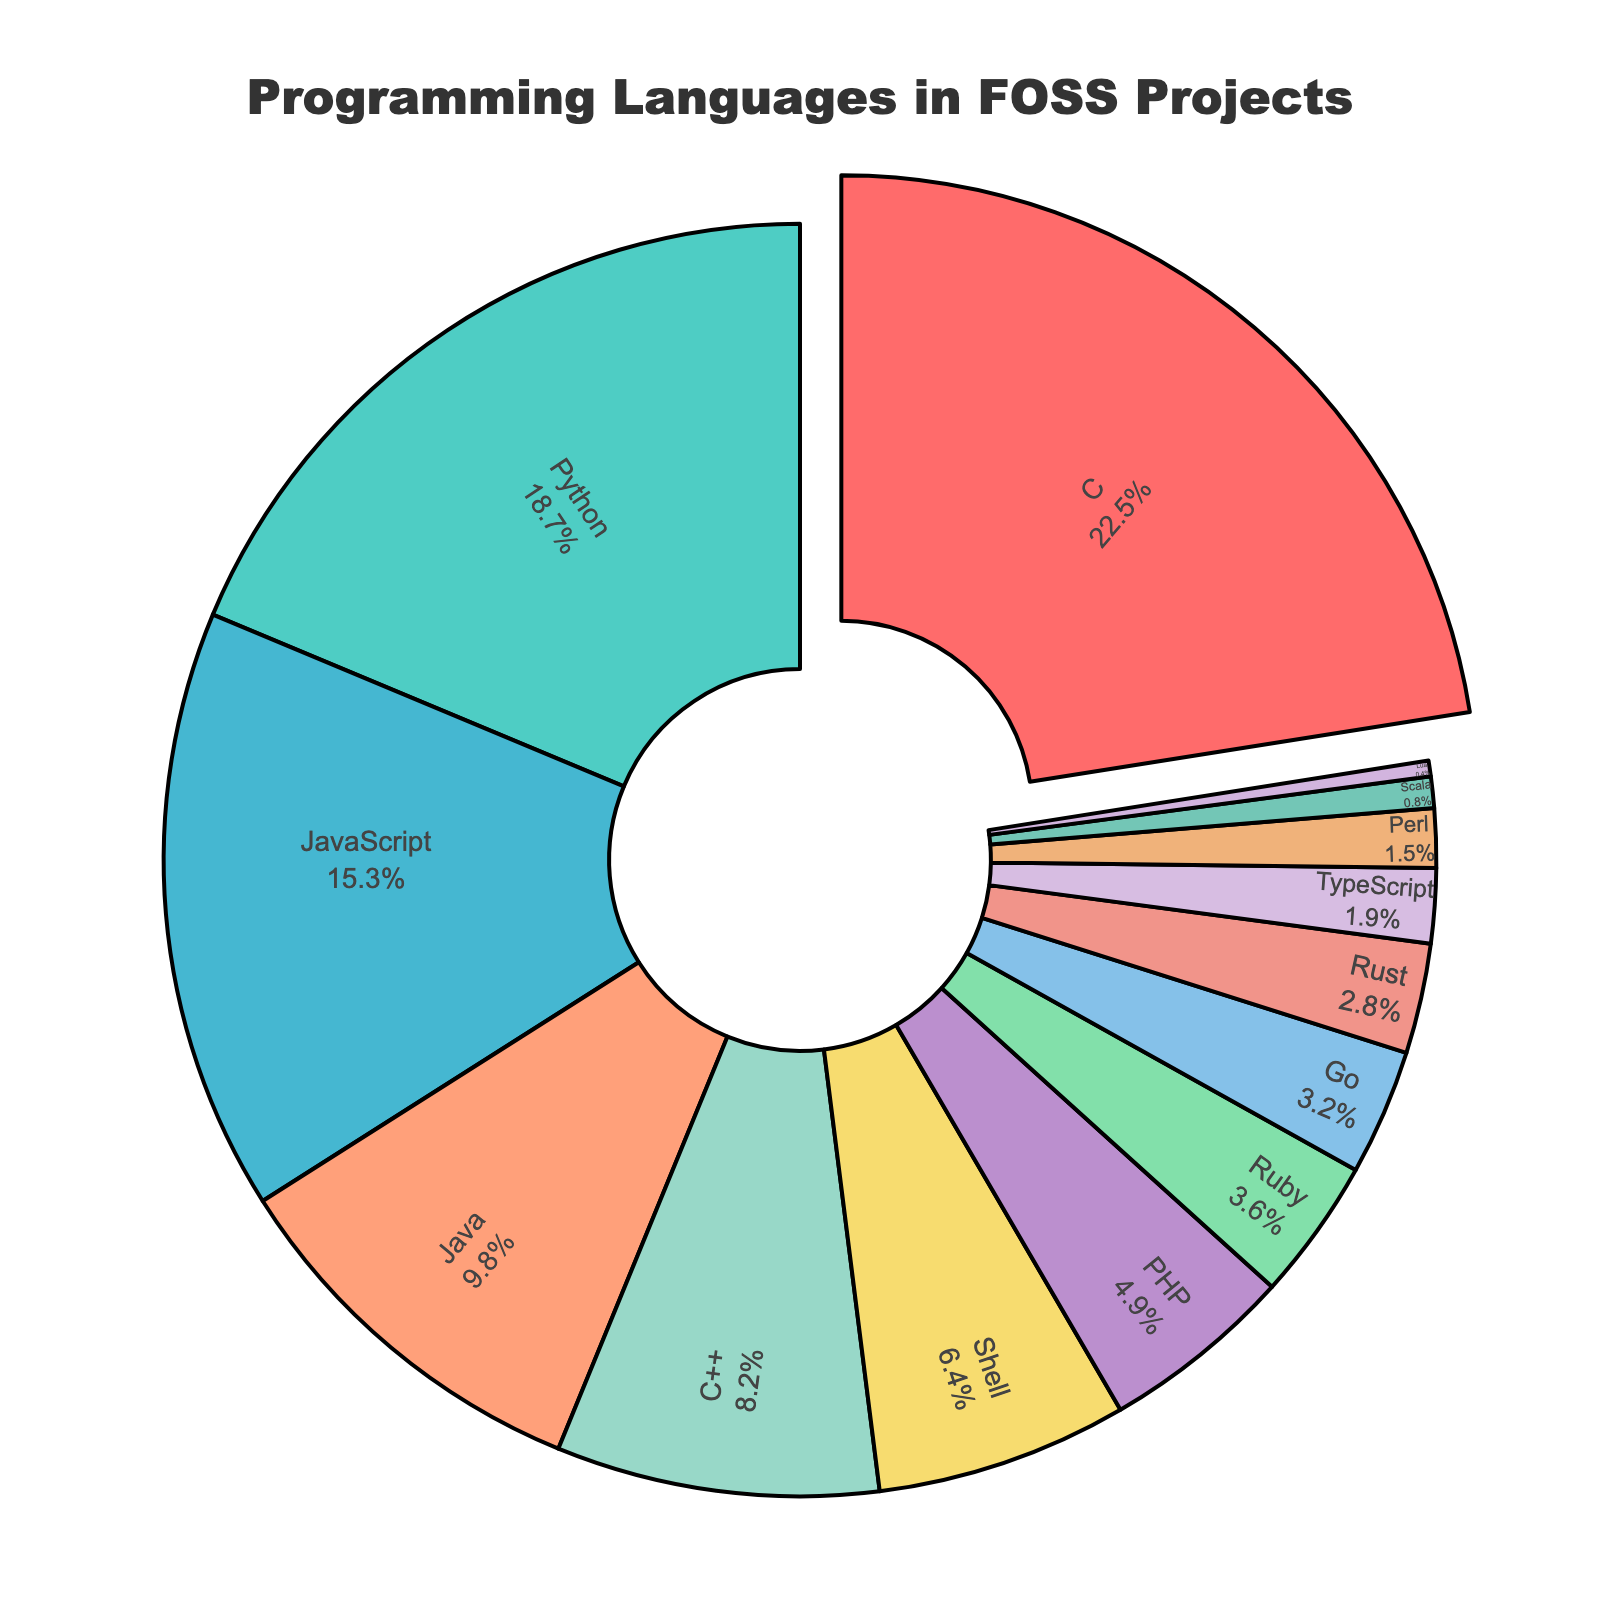Which language accounts for the largest percentage of use in FOSS projects? The pie chart shows each programming language's percentage of use in FOSS projects with the largest segment highlighted. The largest percentage indicated is for C.
Answer: C What is the combined percentage of JavaScript and Python usage? According to the pie chart, JavaScript accounts for 15.3% and Python accounts for 18.7%. Adding these two gives 15.3% + 18.7% = 34%.
Answer: 34% How much more is Python used compared to Rust? The pie chart shows that Python accounts for 18.7% and Rust accounts for 2.8%. The difference is 18.7% - 2.8% = 15.9%.
Answer: 15.9% Which languages have a smaller percentage than Go? The pie chart lists the percentages for each language. Go is 3.2%, and the languages with smaller percentages are Rust (2.8%), TypeScript (1.9%), Perl (1.5%), Scala (0.8%), and Lua (0.4%).
Answer: Rust, TypeScript, Perl, Scala, Lua What is the total percentage for languages that account for less than 5%? Adding the percentages of languages under 5% (PHP, Ruby, Go, Rust, TypeScript, Perl, Scala, Lua) gives 4.9% + 3.6% + 3.2% + 2.8% + 1.9% + 1.5% + 0.8% + 0.4% = 19.1%.
Answer: 19.1% Which language uses a green color segment in the pie chart? The green segment in the pie chart corresponds to JavaScript.
Answer: JavaScript Is the percentage of C++ usage higher or lower than Java? The pie chart shows C++ at 8.2% and Java at 9.8%. C++ usage is lower than Java.
Answer: Lower What is the combined usage percentage of the top 3 most used languages? Adding the percentages of the top 3 languages, which are C (22.5%), Python (18.7%), and JavaScript (15.3%), gives 22.5% + 18.7% + 15.3% = 56.5%.
Answer: 56.5% By how much does Shell usage exceed Go usage? The pie chart shows Shell at 6.4% and Go at 3.2%. The difference is 6.4% - 3.2% = 3.2%.
Answer: 3.2% What is the approximate average usage percentage of the listed languages? Summing the percentages of all languages (22.5 + 18.7 + 15.3 + 9.8 + 8.2 + 6.4 + 4.9 + 3.6 + 3.2 + 2.8 + 1.9 + 1.5 + 0.8 + 0.4 = 100) and dividing by the number of languages (14) gives an average of 100/14 ≈ 7.14%.
Answer: 7.14% 